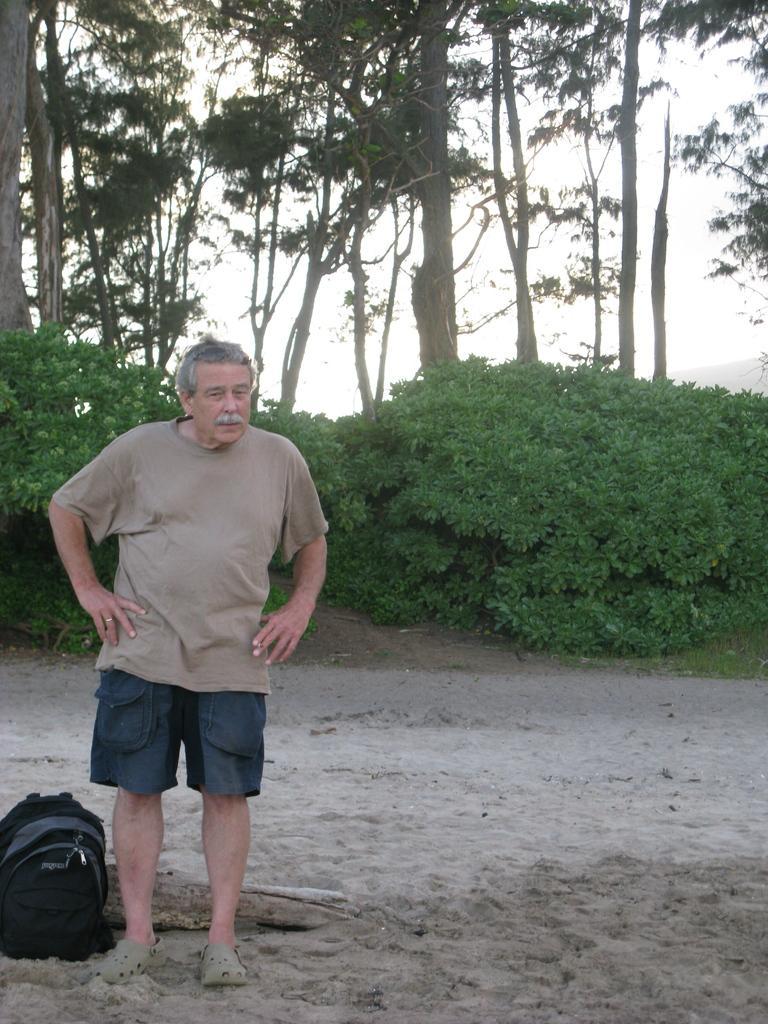Please provide a concise description of this image. This image is taken in outdoors. In the left side of the image a man is standing, beside him there is a backpack. In the bottom of the image there is a sand. In the background there are many trees and plants and sky with clouds. 